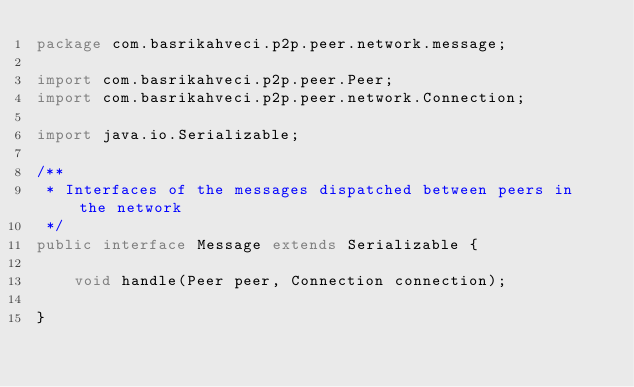<code> <loc_0><loc_0><loc_500><loc_500><_Java_>package com.basrikahveci.p2p.peer.network.message;

import com.basrikahveci.p2p.peer.Peer;
import com.basrikahveci.p2p.peer.network.Connection;

import java.io.Serializable;

/**
 * Interfaces of the messages dispatched between peers in the network
 */
public interface Message extends Serializable {

    void handle(Peer peer, Connection connection);

}
</code> 